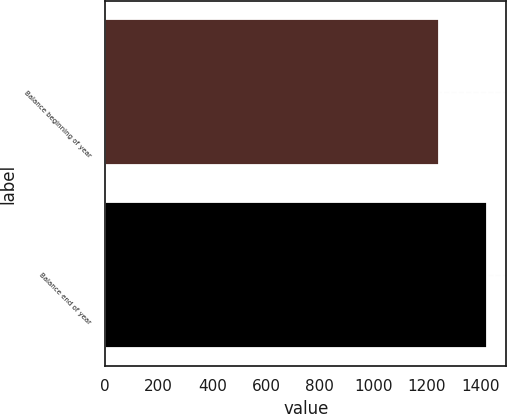Convert chart to OTSL. <chart><loc_0><loc_0><loc_500><loc_500><bar_chart><fcel>Balance beginning of year<fcel>Balance end of year<nl><fcel>1246<fcel>1425<nl></chart> 